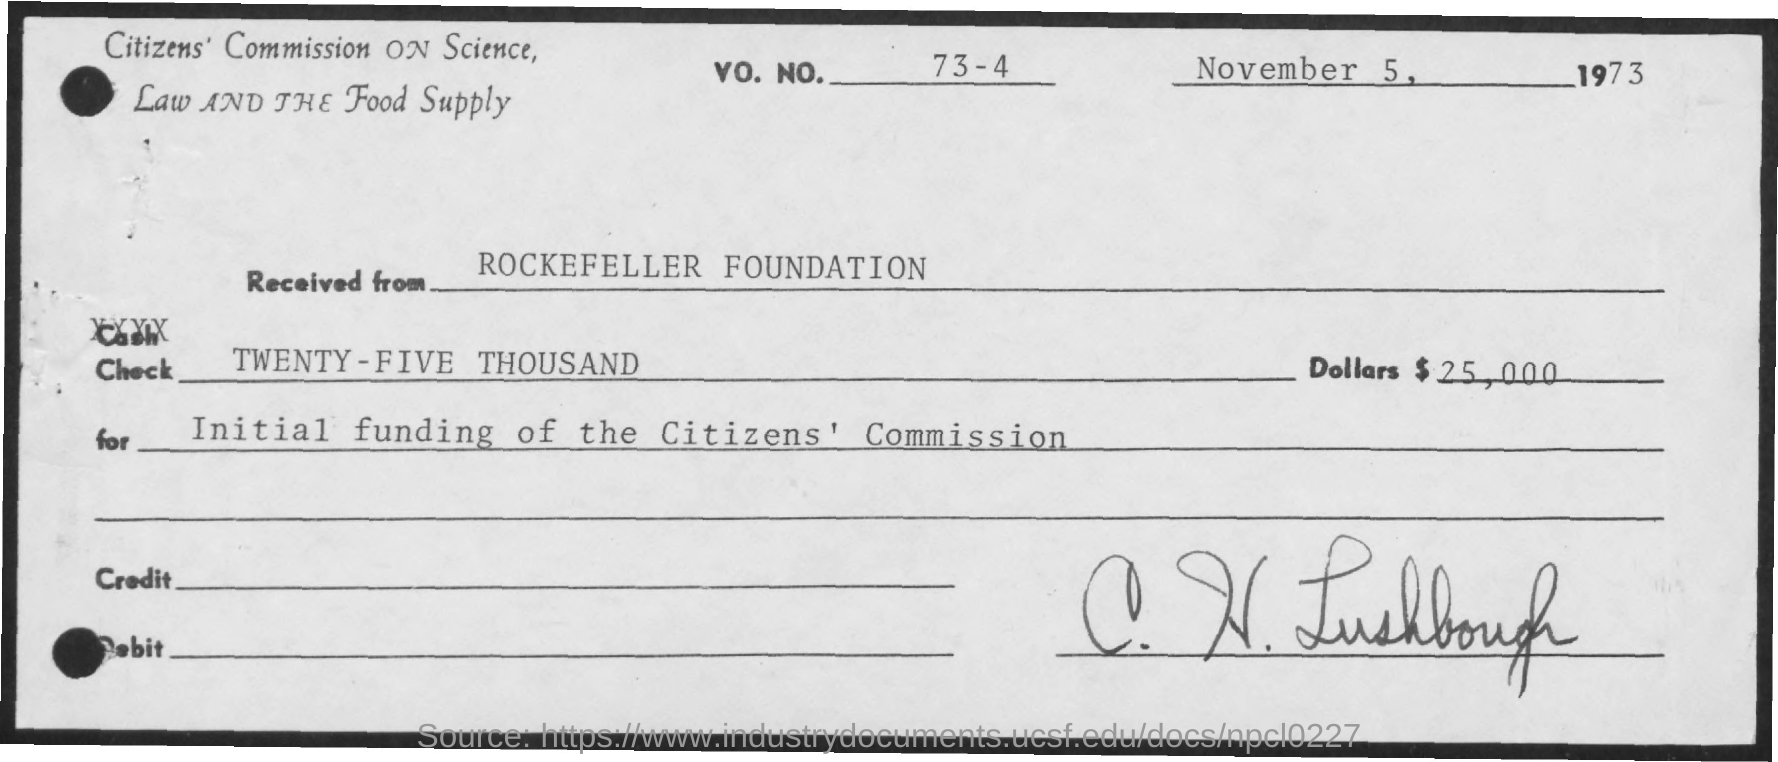What is the date mentioned in the check ?
Offer a very short reply. November 5, 1973. What is the vo. no. mentioned ?
Your answer should be compact. 73-4. From whom the check wwas received ?
Make the answer very short. Rockefeller Foundation. What is the amount shown in the check ?
Keep it short and to the point. $ 25,000. What is the purpose of this check ?
Offer a terse response. Initial funding of the citizen's commission. 